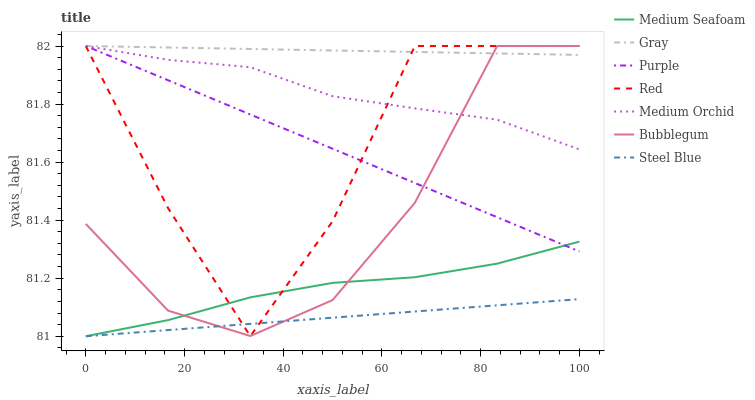Does Steel Blue have the minimum area under the curve?
Answer yes or no. Yes. Does Gray have the maximum area under the curve?
Answer yes or no. Yes. Does Purple have the minimum area under the curve?
Answer yes or no. No. Does Purple have the maximum area under the curve?
Answer yes or no. No. Is Gray the smoothest?
Answer yes or no. Yes. Is Red the roughest?
Answer yes or no. Yes. Is Purple the smoothest?
Answer yes or no. No. Is Purple the roughest?
Answer yes or no. No. Does Steel Blue have the lowest value?
Answer yes or no. Yes. Does Purple have the lowest value?
Answer yes or no. No. Does Red have the highest value?
Answer yes or no. Yes. Does Steel Blue have the highest value?
Answer yes or no. No. Is Medium Seafoam less than Medium Orchid?
Answer yes or no. Yes. Is Purple greater than Steel Blue?
Answer yes or no. Yes. Does Gray intersect Red?
Answer yes or no. Yes. Is Gray less than Red?
Answer yes or no. No. Is Gray greater than Red?
Answer yes or no. No. Does Medium Seafoam intersect Medium Orchid?
Answer yes or no. No. 